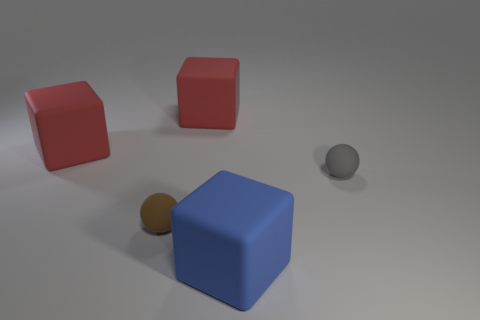Add 1 blue blocks. How many objects exist? 6 Subtract all blocks. How many objects are left? 2 Add 5 large red blocks. How many large red blocks are left? 7 Add 4 big rubber cylinders. How many big rubber cylinders exist? 4 Subtract 0 yellow cubes. How many objects are left? 5 Subtract all cubes. Subtract all large red matte objects. How many objects are left? 0 